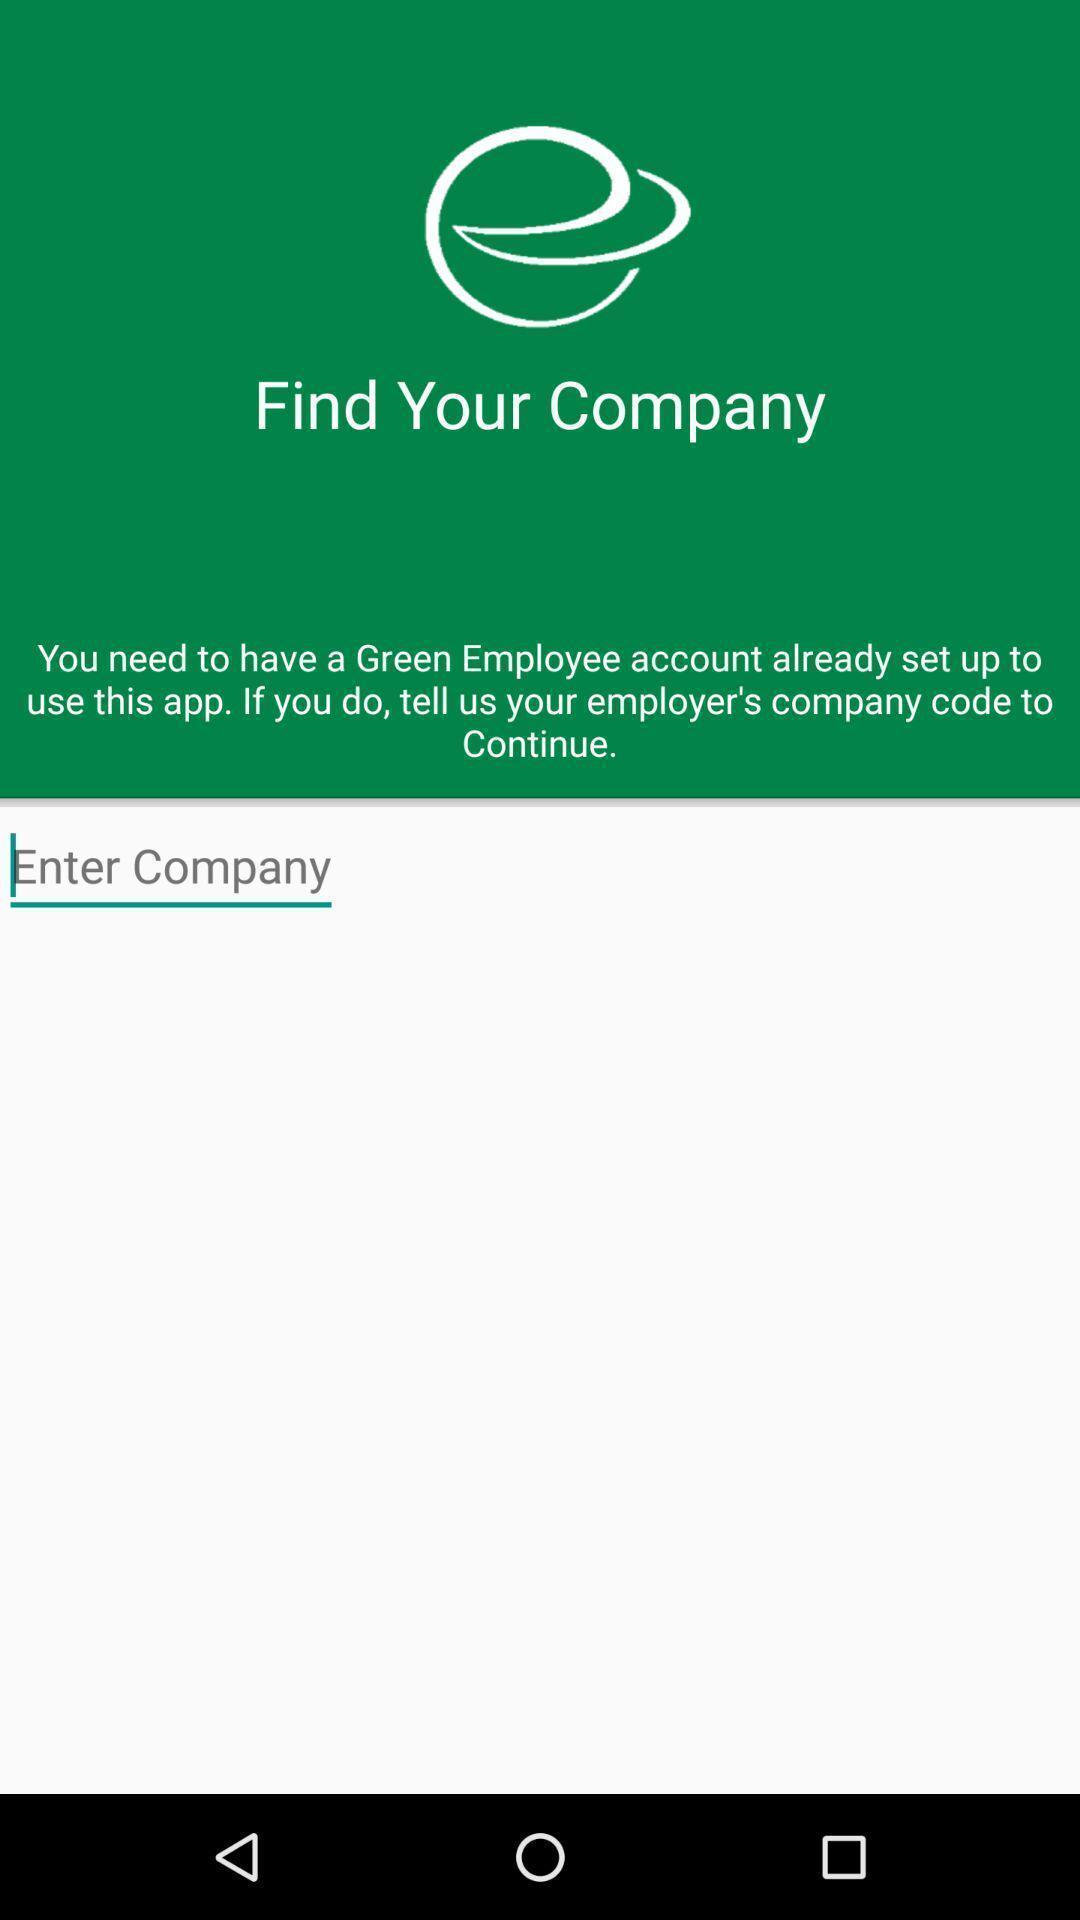What is the overall content of this screenshot? Search page for companies. 